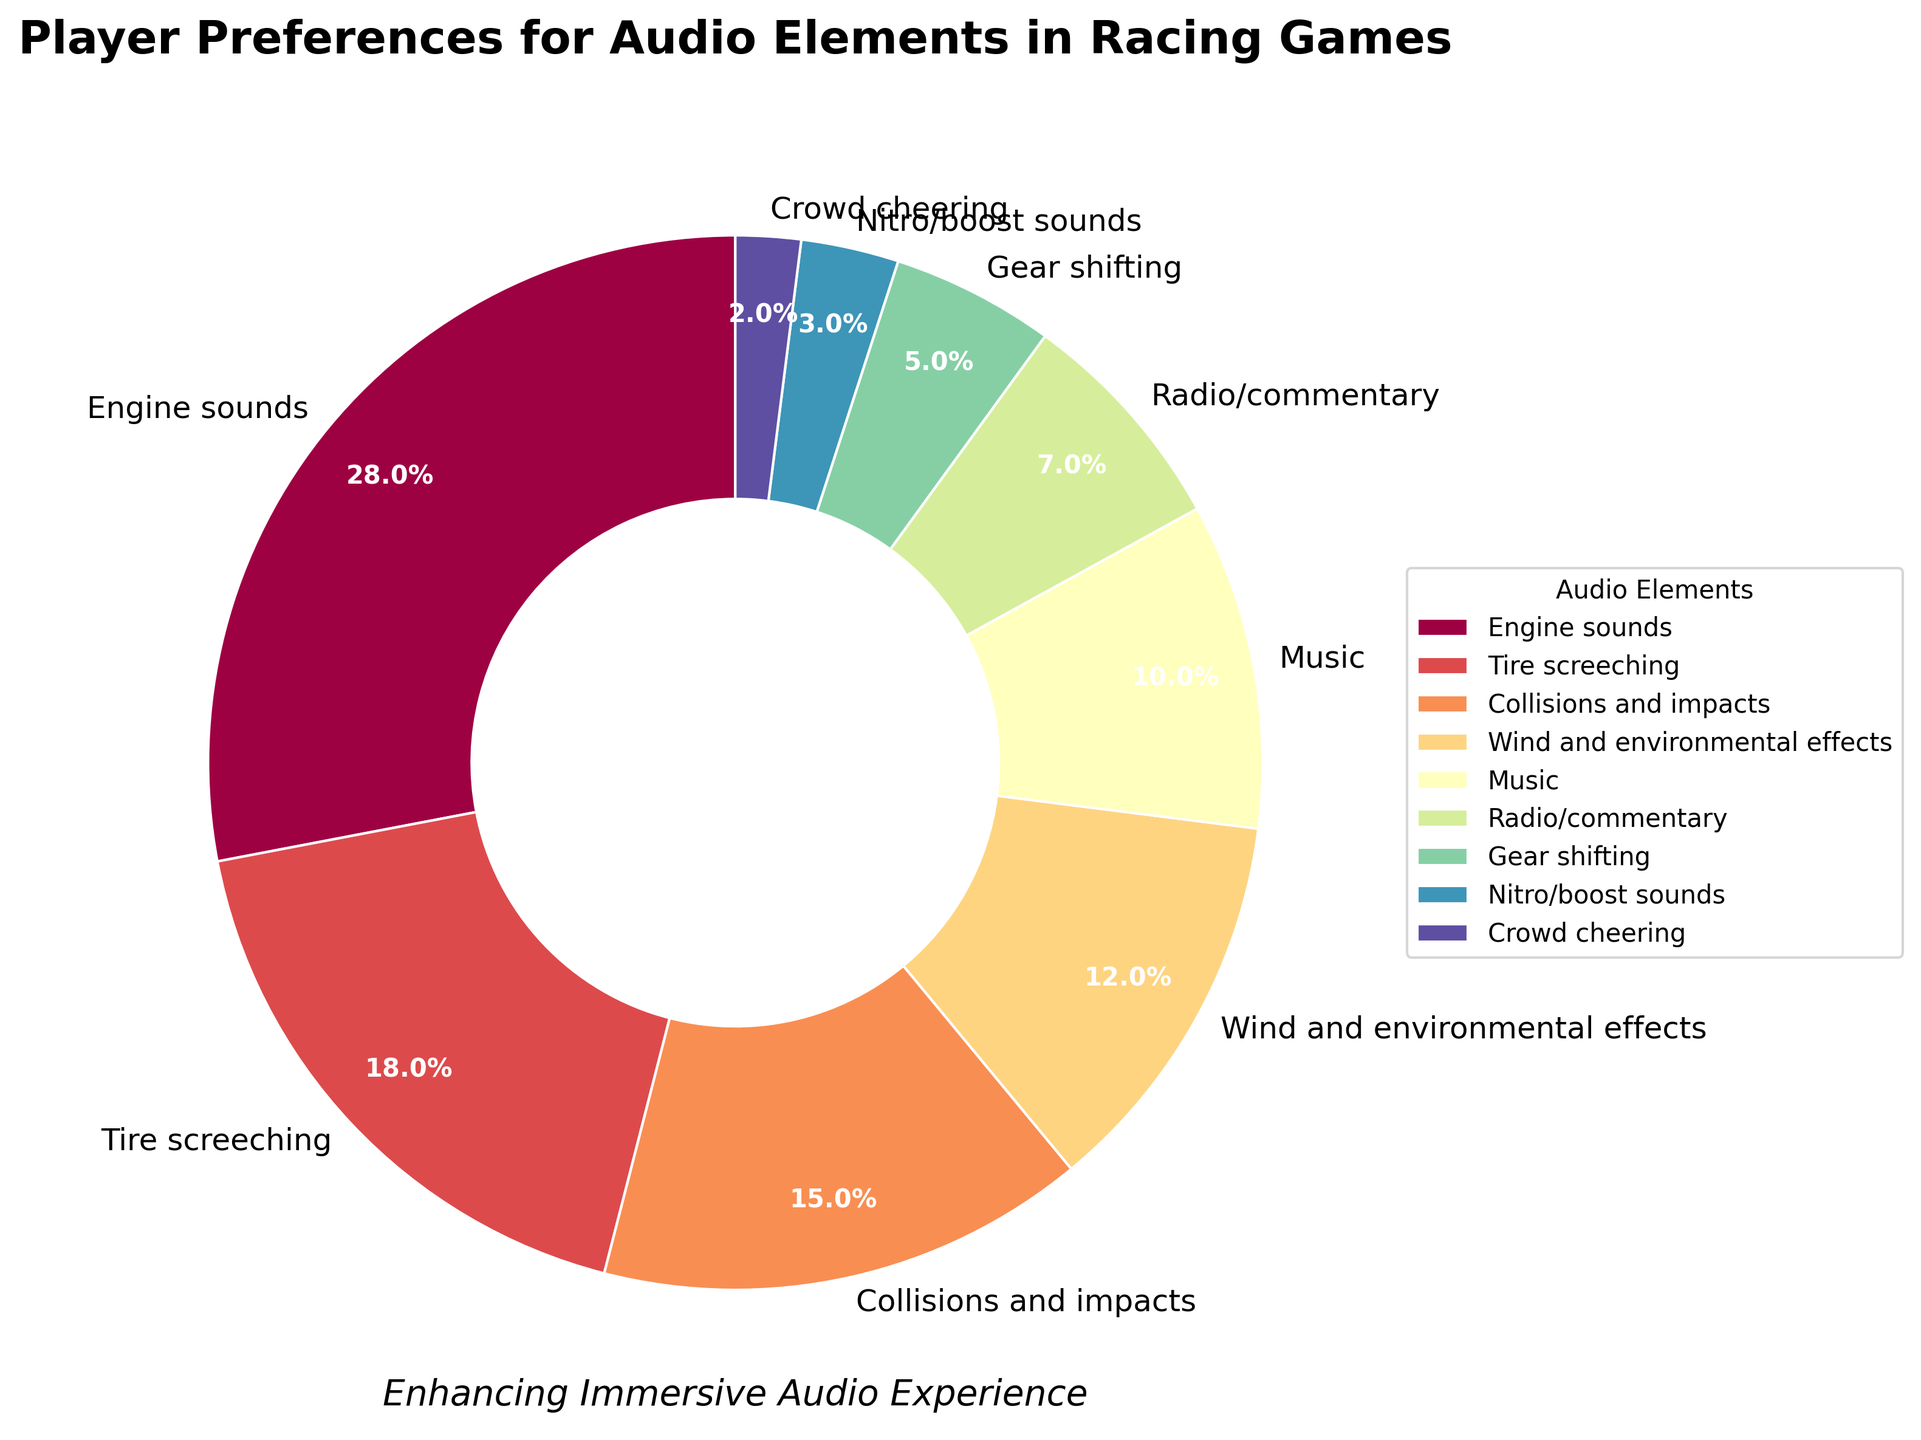What's the most preferred audio element in racing games? The most preferred audio element is represented by the largest wedge in the pie chart.
Answer: Engine sounds Which audio element is preferred by 18% of players? The pie chart shows the preference percentages for each audio element. The one preferred by 18% is Tire screeching.
Answer: Tire screeching How do the preferences for Collisions and impacts compare to Music? Collisions and impacts have a preference of 15%, whereas Music has a preference of 10%. 15% is greater than 10%.
Answer: Collisions and impacts are more preferred than Music What is the combined preference percentage for Engine sounds and Tire screeching? Add the preference percentages for Engine sounds (28%) and Tire screeching (18%): 28% + 18% = 46%.
Answer: 46% Which audio element is least preferred and what is its percentage? The smallest wedge in the pie chart represents the least preferred audio element, which is Crowd cheering at 2%.
Answer: Crowd cheering, 2% Compare the preference between Radio/commentary and Gear shifting. Radio/commentary has a preference of 7% and Gear shifting has a preference of 5%. 7% is greater than 5%.
Answer: Radio/commentary is more preferred than Gear shifting What is the difference in preference between Tire screeching and Wind and environmental effects? Subtract the preference percentage of Wind and environmental effects (12%) from that of Tire screeching (18%): 18% - 12% = 6%.
Answer: 6% What are the total preferences for all sound elements except Music and Crowd cheering? Sum the preference percentages for all elements except Music (10%) and Crowd cheering (2%): 28% + 18% + 15% + 12% + 7% + 5% + 3% = 88%.
Answer: 88% How many audio elements have a preference percentage of 10% or more? Count the elements with a preference percentage of 10% or more: Engine sounds (28%), Tire screeching (18%), Collisions and impacts (15%), Wind and environmental effects (12%), Music (10%). There are 5 such elements.
Answer: 5 How is the preference for Nitro/boost sounds visually represented compared to Gear shifting? Nitro/boost sounds are represented by a smaller wedge compared to Gear shifting in the pie chart. Specifically, Nitro/boost sounds have a preference of 3% while Gear shifting has 5%.
Answer: Nitro/boost sounds have a smaller wedge than Gear shifting 